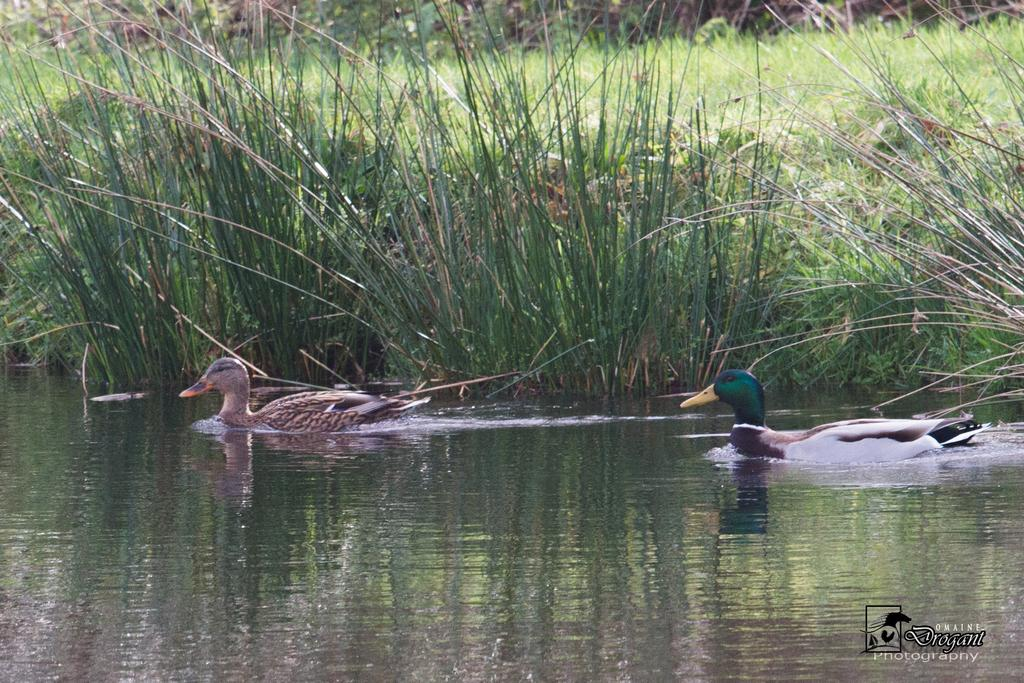What type of animals can be seen in the image? Birds can be seen in the water. What can be seen in the background of the image? There is grass and plants visible in the background of the image. Is there any text or marking in the image? Yes, there is a watermark in the bottom right corner of the image. What type of slope can be seen in the image? There is no slope present in the image; it features birds in the water and a background with grass and plants. 